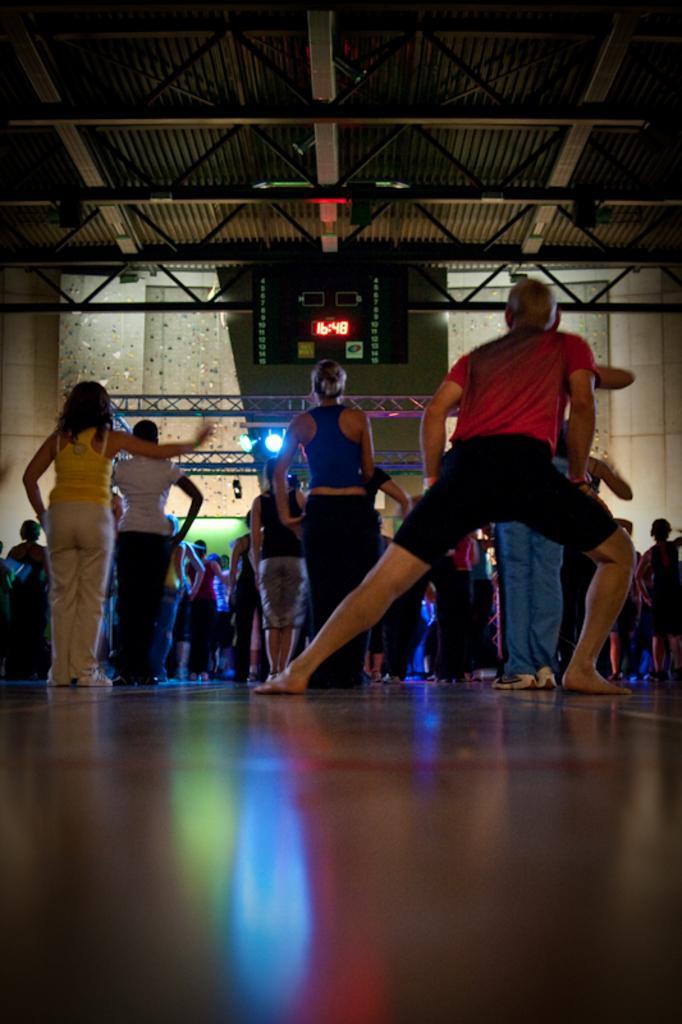In one or two sentences, can you explain what this image depicts? In this image there are group of persons, there is a person truncated towards the right of the image, there is a person truncated towards the left of the image, there is a roof truncated towards the top of the image, there is the wall, there are lights, there is a screen. 